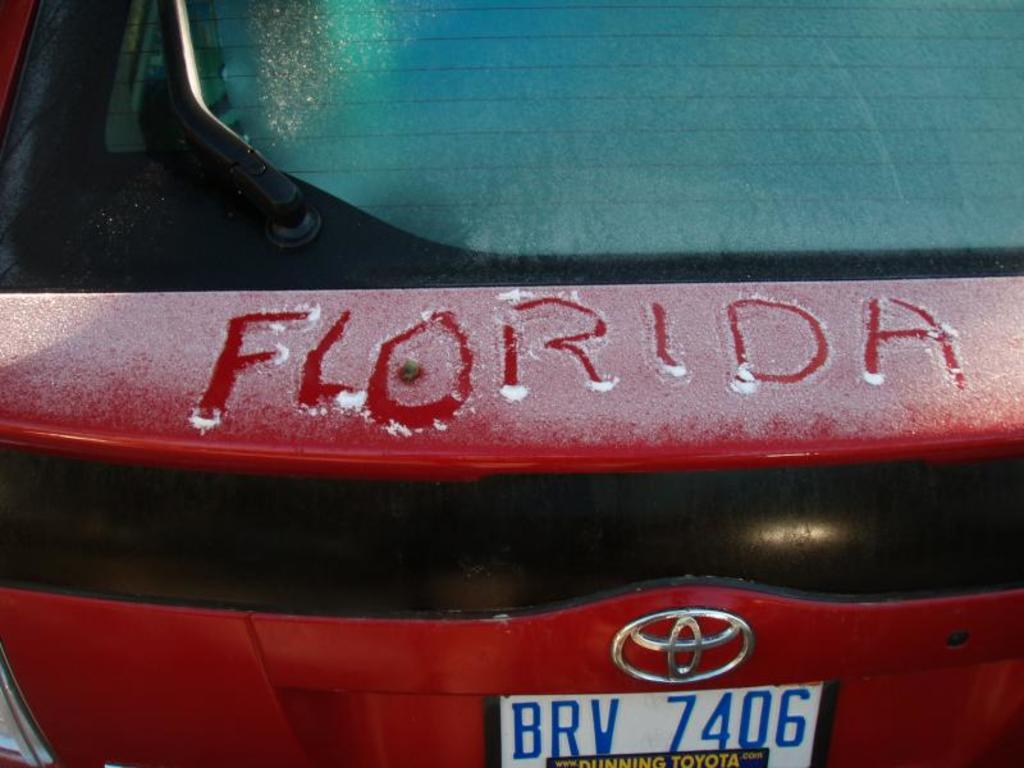<image>
Summarize the visual content of the image. the word Florida on the back of a car 